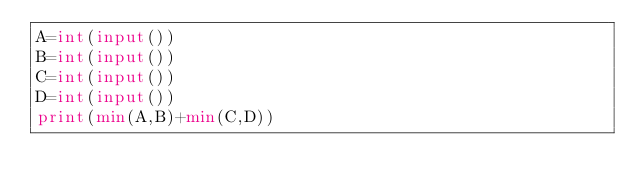<code> <loc_0><loc_0><loc_500><loc_500><_Python_>A=int(input())
B=int(input())
C=int(input())
D=int(input())
print(min(A,B)+min(C,D))</code> 